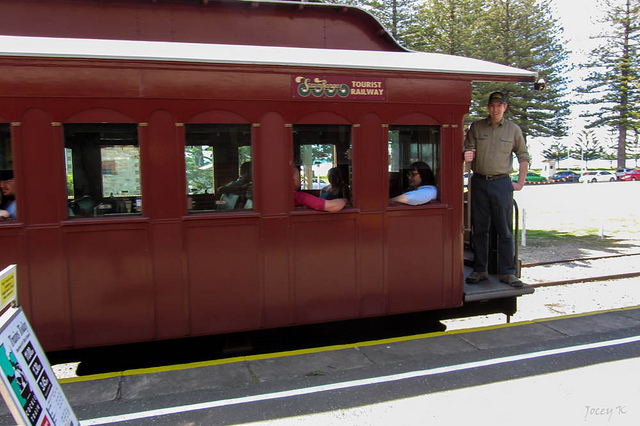Can you describe the atmosphere and the emotions of people in the image? The atmosphere in the image appears to be relaxed and leisurely. The people inside the railway car seem to be enjoying the ride, their expressions calm and content as they look out of the windows. The man standing on the platform of the car seems attentive and responsible, possibly overseeing the boarding process. The bright, sunny day with a clear sky enhances the overall pleasant and cheerful mood of the scene. What kind of journey do you think the passengers are embarking on? Given that this is a tourist railway car, it is likely that the passengers are embarking on a scenic journey through a picturesque landscape. They might be exploring historical sites, beautiful natural vistas, or charming small towns along the route. The relaxed demeanor of the passengers suggests they are on a leisurely trip, possibly to enjoy some recreational and educational experiences. If this image were part of a story, what would the title of the chapter be? A Journey Through Time: Memories on the Heritage Railway Imagine you are the man standing on the platform. Describe your day and thoughts. As the man standing on the platform, my day is filled with a sense of duty and a touch of nostalgia. From the early morning, I ensure that everything is in perfect order for the passengers' safety and comfort. Each day brings a new group of eager tourists, and I take pride in being part of their journey, making sure they experience the beauty of the historical railway line. I often catch snippets of their conversations, filled with joy and wonder, which brings a smile to my face. Standing here, I feel connected to the past, to the countless journeys this railway has facilitated, and to the simple happiness it continues to bring to people's lives. Could you tell me what the surroundings outside the railway look like? Give me two different lengths of descriptions. Short description: The railway car is surrounded by a serene, tree-filled landscape with a few parked cars visible in the distance, suggesting a recreational area nearby. Long description: The scenic surroundings outside the railway car are filled with tall, green trees, their leaves gently swaying in the breeze. Below the clear blue sky, the sunlight bathes the area in a warm glow, casting playful shadows on the ground. A few parked cars can be seen in the background, hinting at a recreational park where families and tourists gather to enjoy the day. The peaceful and inviting atmosphere complements the nostalgic charm of the tourist railway, creating a perfect escape from the hustle and bustle of daily life. 